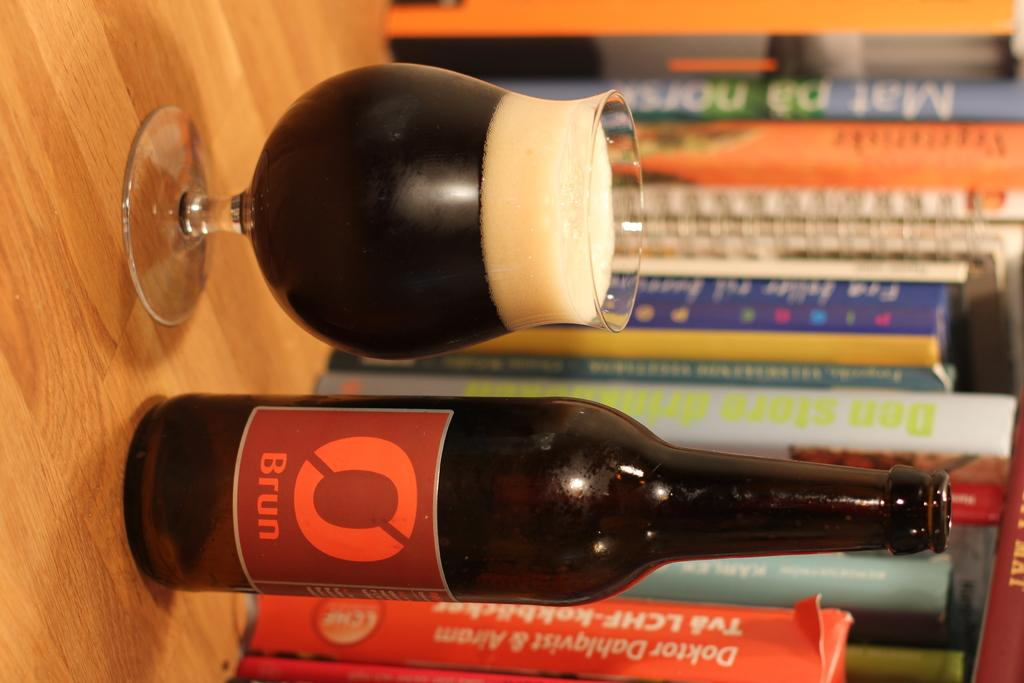<image>
Describe the image concisely. a bottle of Brun that is red in color 